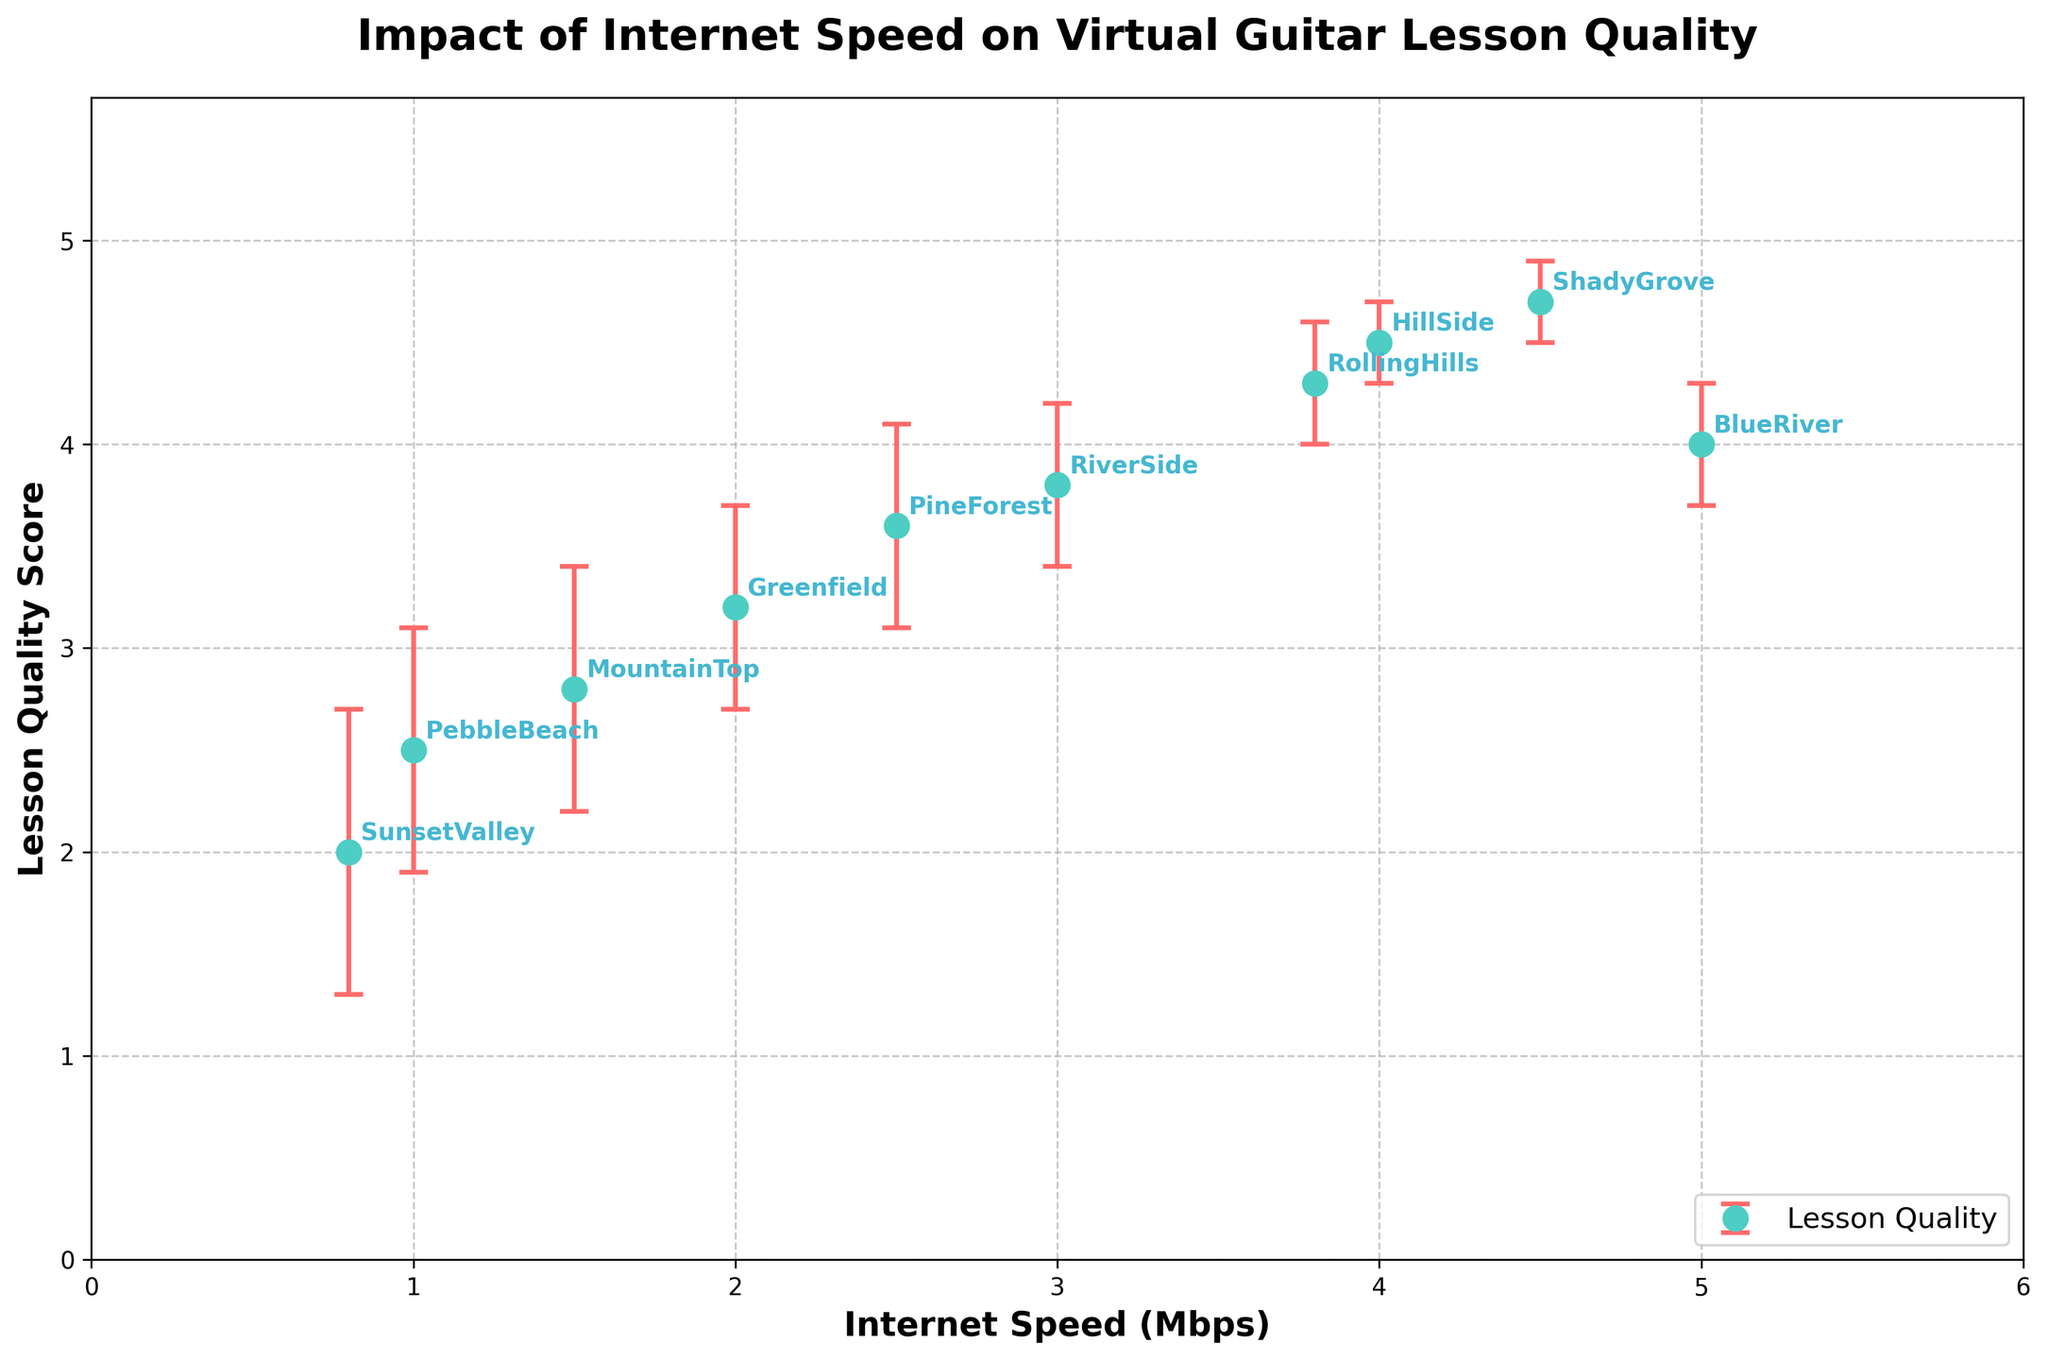What's the title of the figure? The title is located at the top of the figure above the plot, providing a summary of what the figure is about.
Answer: Impact of Internet Speed on Virtual Guitar Lesson Quality How many villages are represented in the plot? Each marker on the plot represents a village. Counting all markers gives the total number of villages.
Answer: 10 Which village has the highest lesson quality score? Identify the marker with the highest y-axis value and refer to the annotated label next to it.
Answer: ShadyGrove What is the lesson quality score for the village with the lowest internet speed? Find the marker with the lowest x-axis value and read its corresponding y-axis value.
Answer: 2.0 What's the average internet speed of all the villages? Add up all internet speed values and divide by the number of villages. (2 + 5 + 1.5 + 0.8 + 3 + 4 + 2.5 + 1 + 4.5 + 3.8) / 10 = 2.86
Answer: 2.86 Mbps Which village has the largest error in lesson quality score? Compare the error bars to see which is the longest, then identify the corresponding village label.
Answer: SunsetValley Between which two villages does the lesson quality score improvement seem the most significant? Compare the differences in lesson quality scores between pairs of villages and identify the largest difference.
Answer: SunsetValley and ShadyGrove What is the lesson quality score range from the village with the maximum internet speed? Identify the village with the highest x-axis value, then read the y-axis value and add/subtract the error value to get the range. ShadyGrove's lesson quality score is 4.7 ± 0.2, giving a range from 4.5 to 4.9.
Answer: 4.5 to 4.9 Is there a general trend between internet speed and lesson quality score? By observing the overall distribution of markers, determine if scores increase or decrease with internet speed.
Answer: Yes, higher internet speed tends to correlate with higher lesson quality scores 